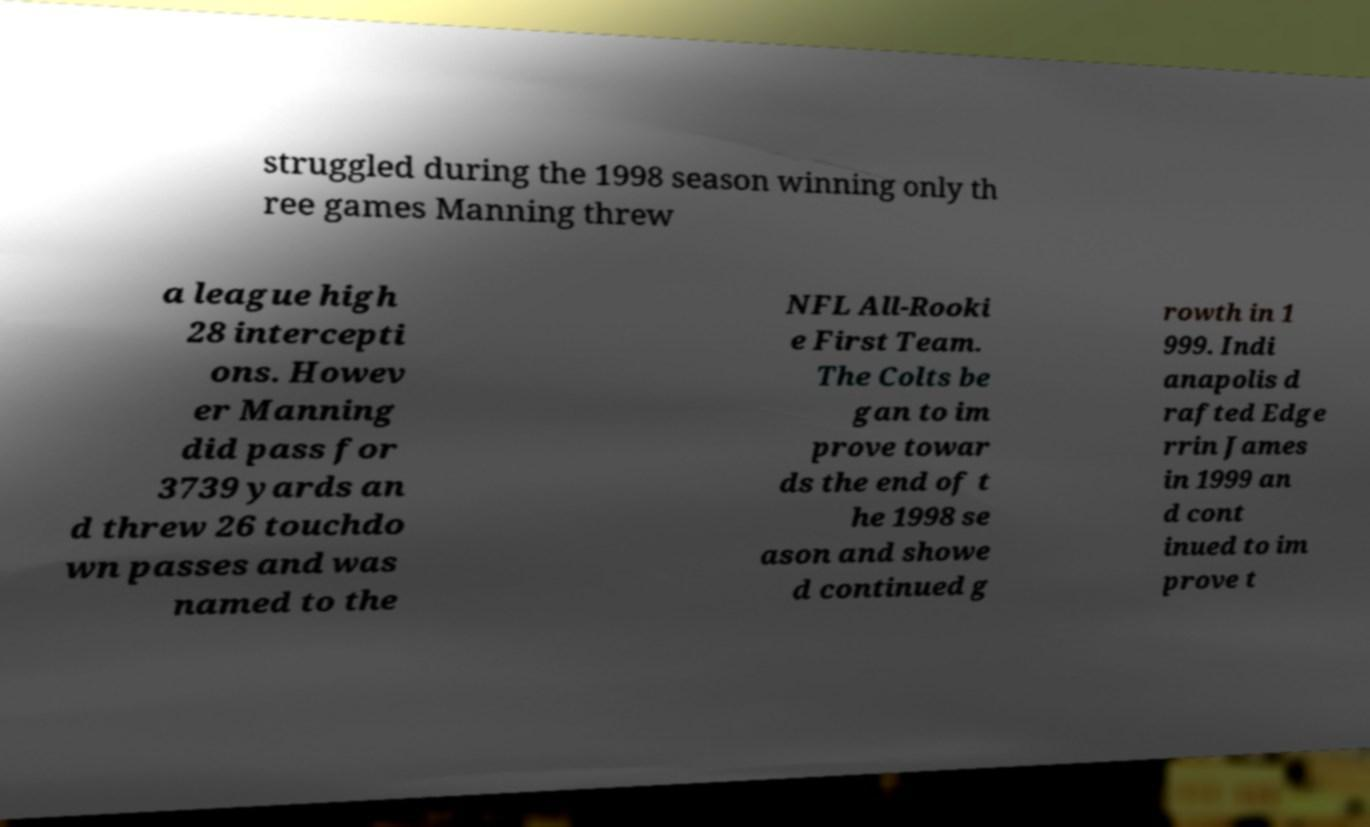Please read and relay the text visible in this image. What does it say? struggled during the 1998 season winning only th ree games Manning threw a league high 28 intercepti ons. Howev er Manning did pass for 3739 yards an d threw 26 touchdo wn passes and was named to the NFL All-Rooki e First Team. The Colts be gan to im prove towar ds the end of t he 1998 se ason and showe d continued g rowth in 1 999. Indi anapolis d rafted Edge rrin James in 1999 an d cont inued to im prove t 